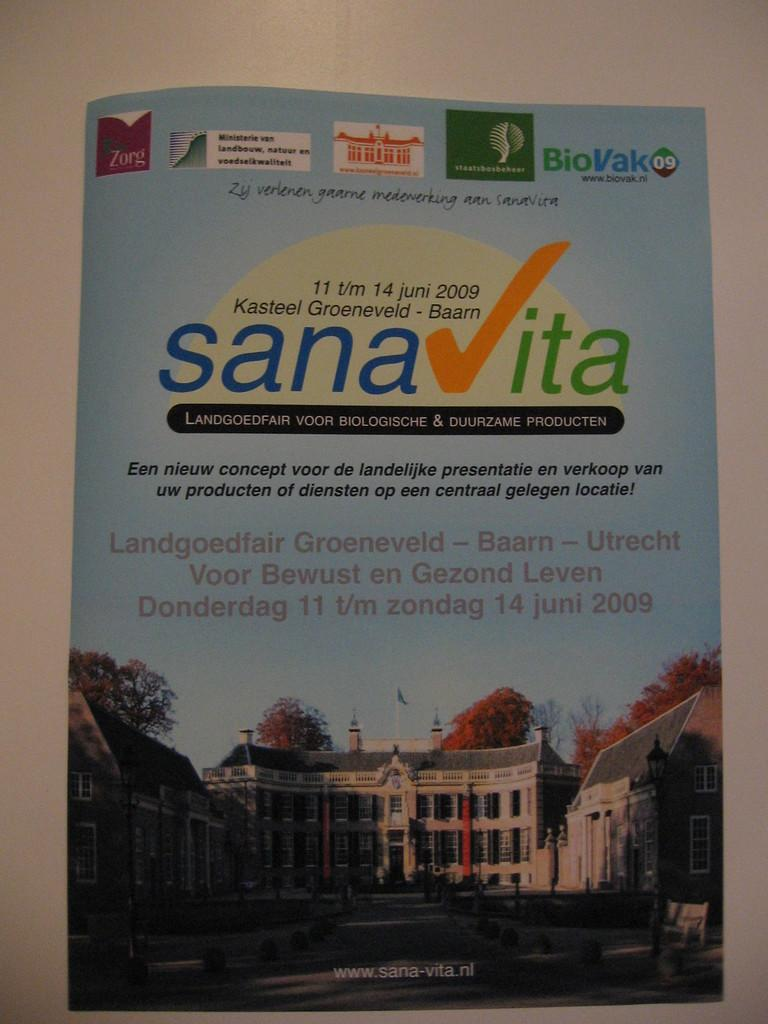<image>
Render a clear and concise summary of the photo. Poster on a wall that says "Sanvita" and shows a building. 